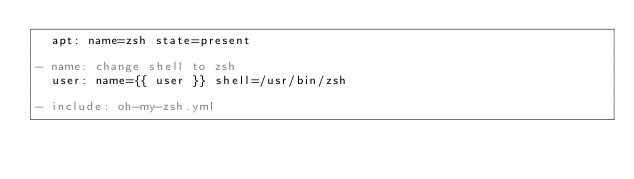Convert code to text. <code><loc_0><loc_0><loc_500><loc_500><_YAML_>  apt: name=zsh state=present

- name: change shell to zsh
  user: name={{ user }} shell=/usr/bin/zsh

- include: oh-my-zsh.yml
</code> 